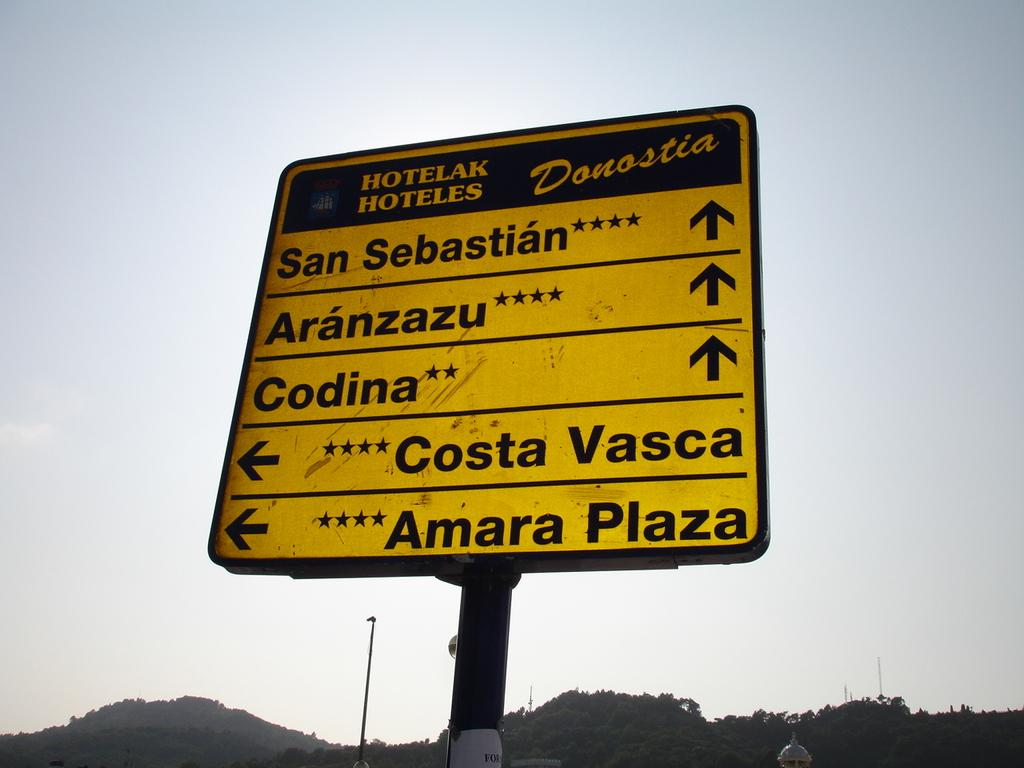<image>
Relay a brief, clear account of the picture shown. Yellow street sigh which says "San Sebastian" on top. 